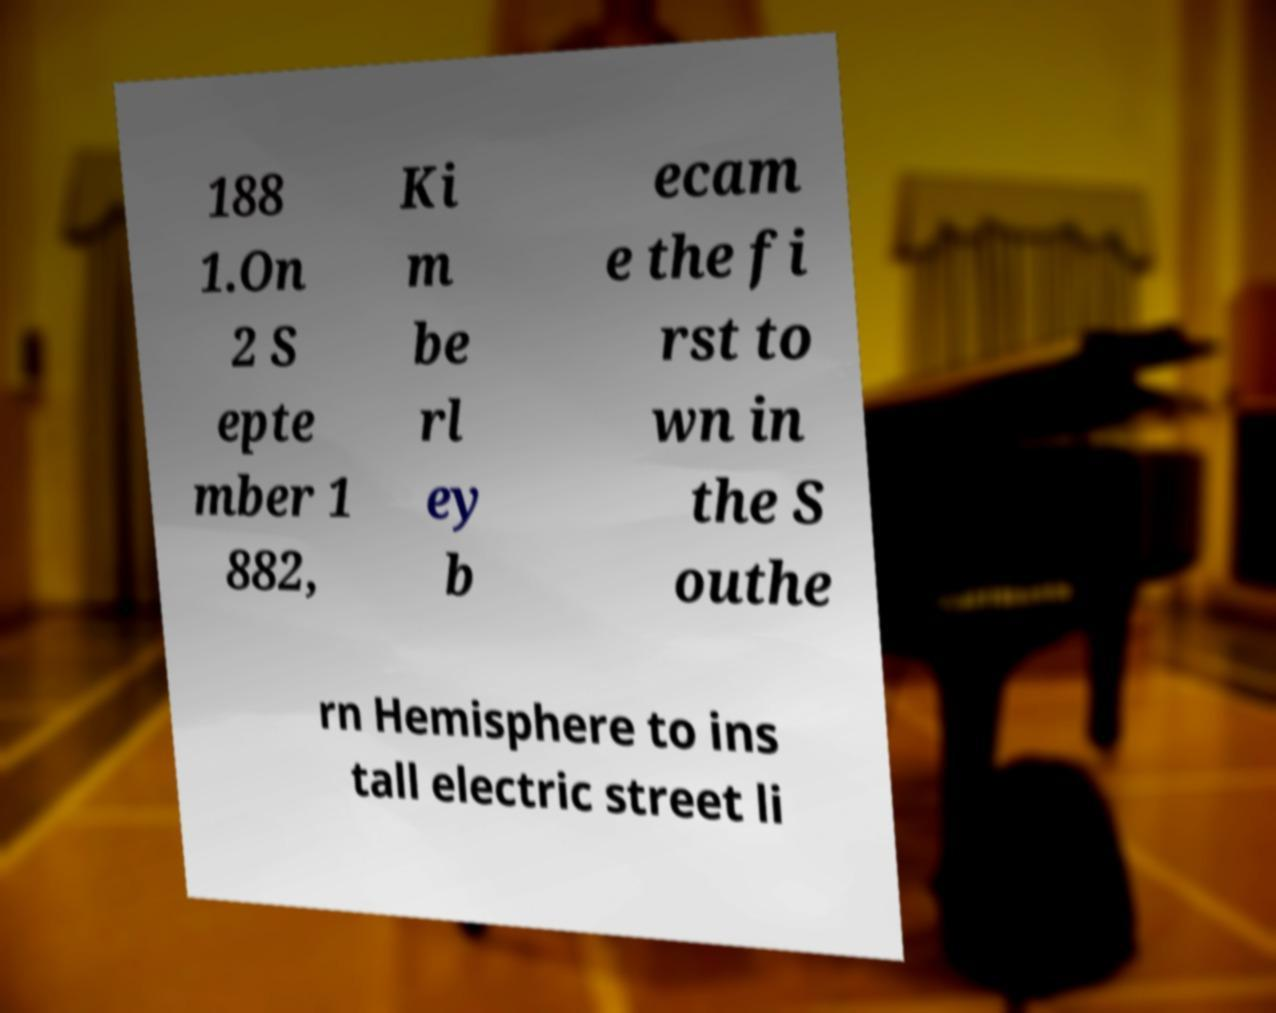Can you read and provide the text displayed in the image?This photo seems to have some interesting text. Can you extract and type it out for me? 188 1.On 2 S epte mber 1 882, Ki m be rl ey b ecam e the fi rst to wn in the S outhe rn Hemisphere to ins tall electric street li 